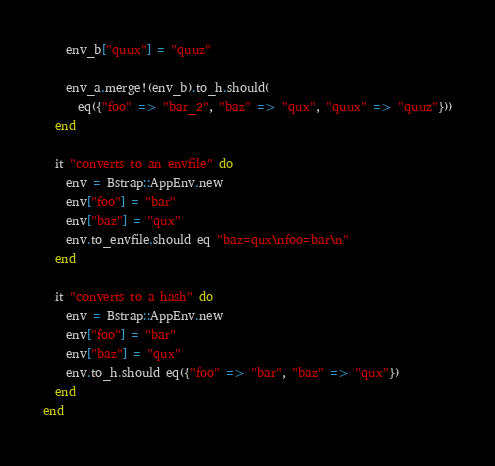<code> <loc_0><loc_0><loc_500><loc_500><_Crystal_>    env_b["quux"] = "quuz"

    env_a.merge!(env_b).to_h.should(
      eq({"foo" => "bar_2", "baz" => "qux", "quux" => "quuz"}))
  end

  it "converts to an envfile" do
    env = Bstrap::AppEnv.new
    env["foo"] = "bar"
    env["baz"] = "qux"
    env.to_envfile.should eq "baz=qux\nfoo=bar\n"
  end

  it "converts to a hash" do
    env = Bstrap::AppEnv.new
    env["foo"] = "bar"
    env["baz"] = "qux"
    env.to_h.should eq({"foo" => "bar", "baz" => "qux"})
  end
end
</code> 